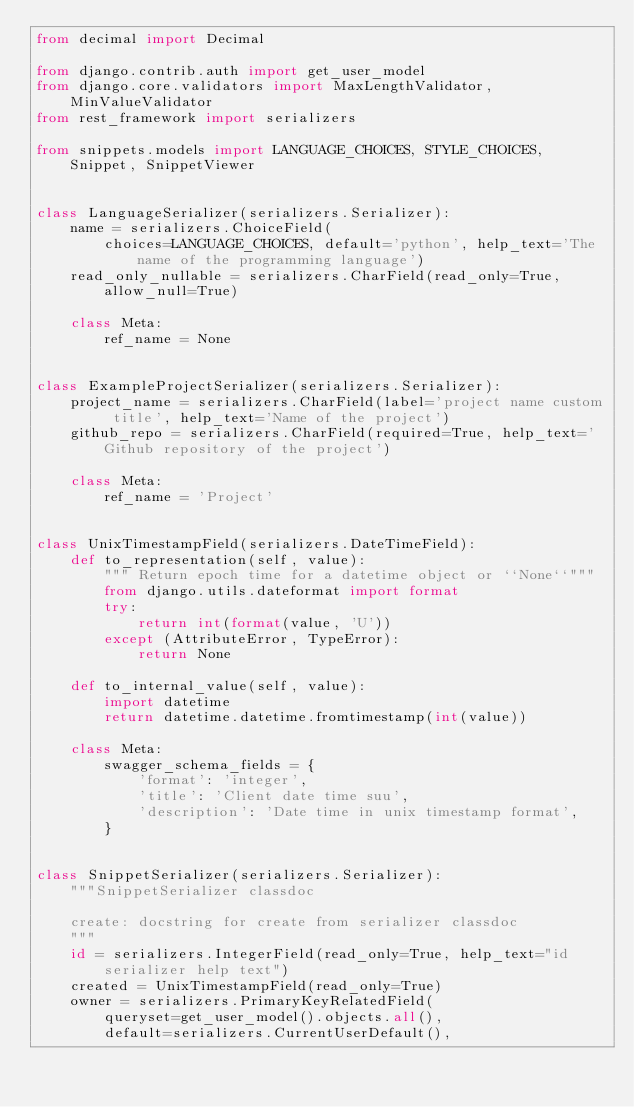Convert code to text. <code><loc_0><loc_0><loc_500><loc_500><_Python_>from decimal import Decimal

from django.contrib.auth import get_user_model
from django.core.validators import MaxLengthValidator, MinValueValidator
from rest_framework import serializers

from snippets.models import LANGUAGE_CHOICES, STYLE_CHOICES, Snippet, SnippetViewer


class LanguageSerializer(serializers.Serializer):
    name = serializers.ChoiceField(
        choices=LANGUAGE_CHOICES, default='python', help_text='The name of the programming language')
    read_only_nullable = serializers.CharField(read_only=True, allow_null=True)

    class Meta:
        ref_name = None


class ExampleProjectSerializer(serializers.Serializer):
    project_name = serializers.CharField(label='project name custom title', help_text='Name of the project')
    github_repo = serializers.CharField(required=True, help_text='Github repository of the project')

    class Meta:
        ref_name = 'Project'


class UnixTimestampField(serializers.DateTimeField):
    def to_representation(self, value):
        """ Return epoch time for a datetime object or ``None``"""
        from django.utils.dateformat import format
        try:
            return int(format(value, 'U'))
        except (AttributeError, TypeError):
            return None

    def to_internal_value(self, value):
        import datetime
        return datetime.datetime.fromtimestamp(int(value))

    class Meta:
        swagger_schema_fields = {
            'format': 'integer',
            'title': 'Client date time suu',
            'description': 'Date time in unix timestamp format',
        }


class SnippetSerializer(serializers.Serializer):
    """SnippetSerializer classdoc

    create: docstring for create from serializer classdoc
    """
    id = serializers.IntegerField(read_only=True, help_text="id serializer help text")
    created = UnixTimestampField(read_only=True)
    owner = serializers.PrimaryKeyRelatedField(
        queryset=get_user_model().objects.all(),
        default=serializers.CurrentUserDefault(),</code> 